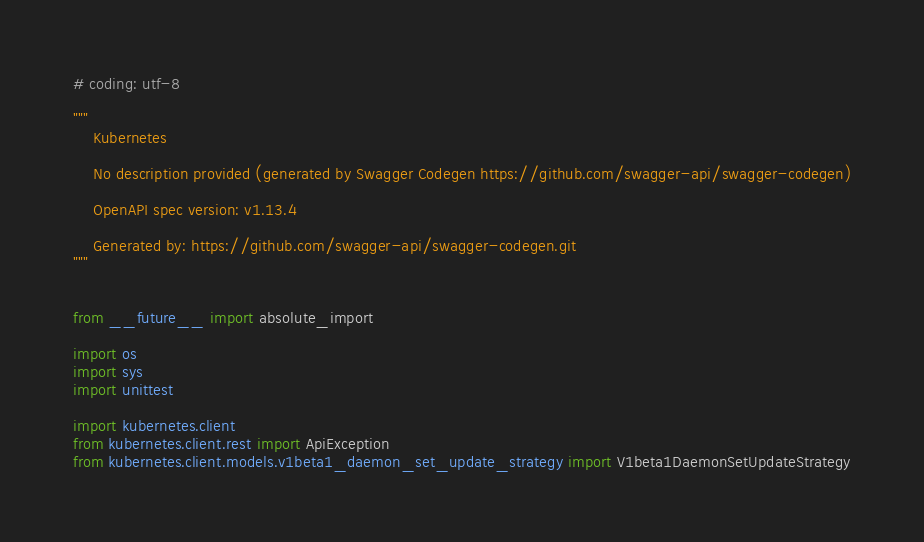Convert code to text. <code><loc_0><loc_0><loc_500><loc_500><_Python_># coding: utf-8

"""
    Kubernetes

    No description provided (generated by Swagger Codegen https://github.com/swagger-api/swagger-codegen)

    OpenAPI spec version: v1.13.4
    
    Generated by: https://github.com/swagger-api/swagger-codegen.git
"""


from __future__ import absolute_import

import os
import sys
import unittest

import kubernetes.client
from kubernetes.client.rest import ApiException
from kubernetes.client.models.v1beta1_daemon_set_update_strategy import V1beta1DaemonSetUpdateStrategy

</code> 